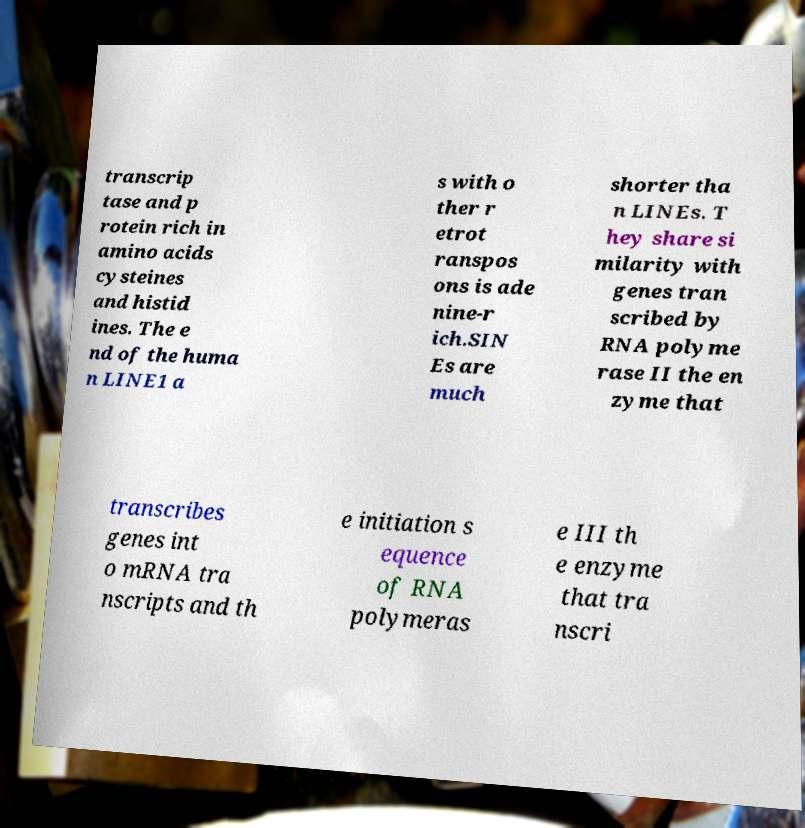Could you extract and type out the text from this image? transcrip tase and p rotein rich in amino acids cysteines and histid ines. The e nd of the huma n LINE1 a s with o ther r etrot ranspos ons is ade nine-r ich.SIN Es are much shorter tha n LINEs. T hey share si milarity with genes tran scribed by RNA polyme rase II the en zyme that transcribes genes int o mRNA tra nscripts and th e initiation s equence of RNA polymeras e III th e enzyme that tra nscri 